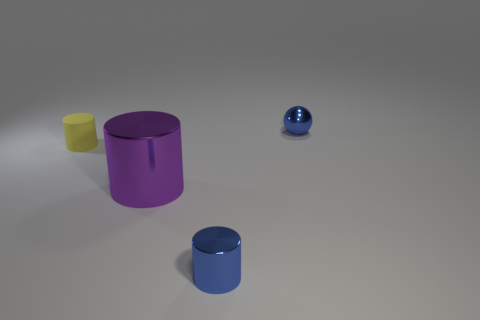There is a small yellow matte cylinder; are there any purple metal things to the right of it? Yes, to the right of the small yellow matte cylinder, there is a purple metallic cylinder with a reflective surface. 